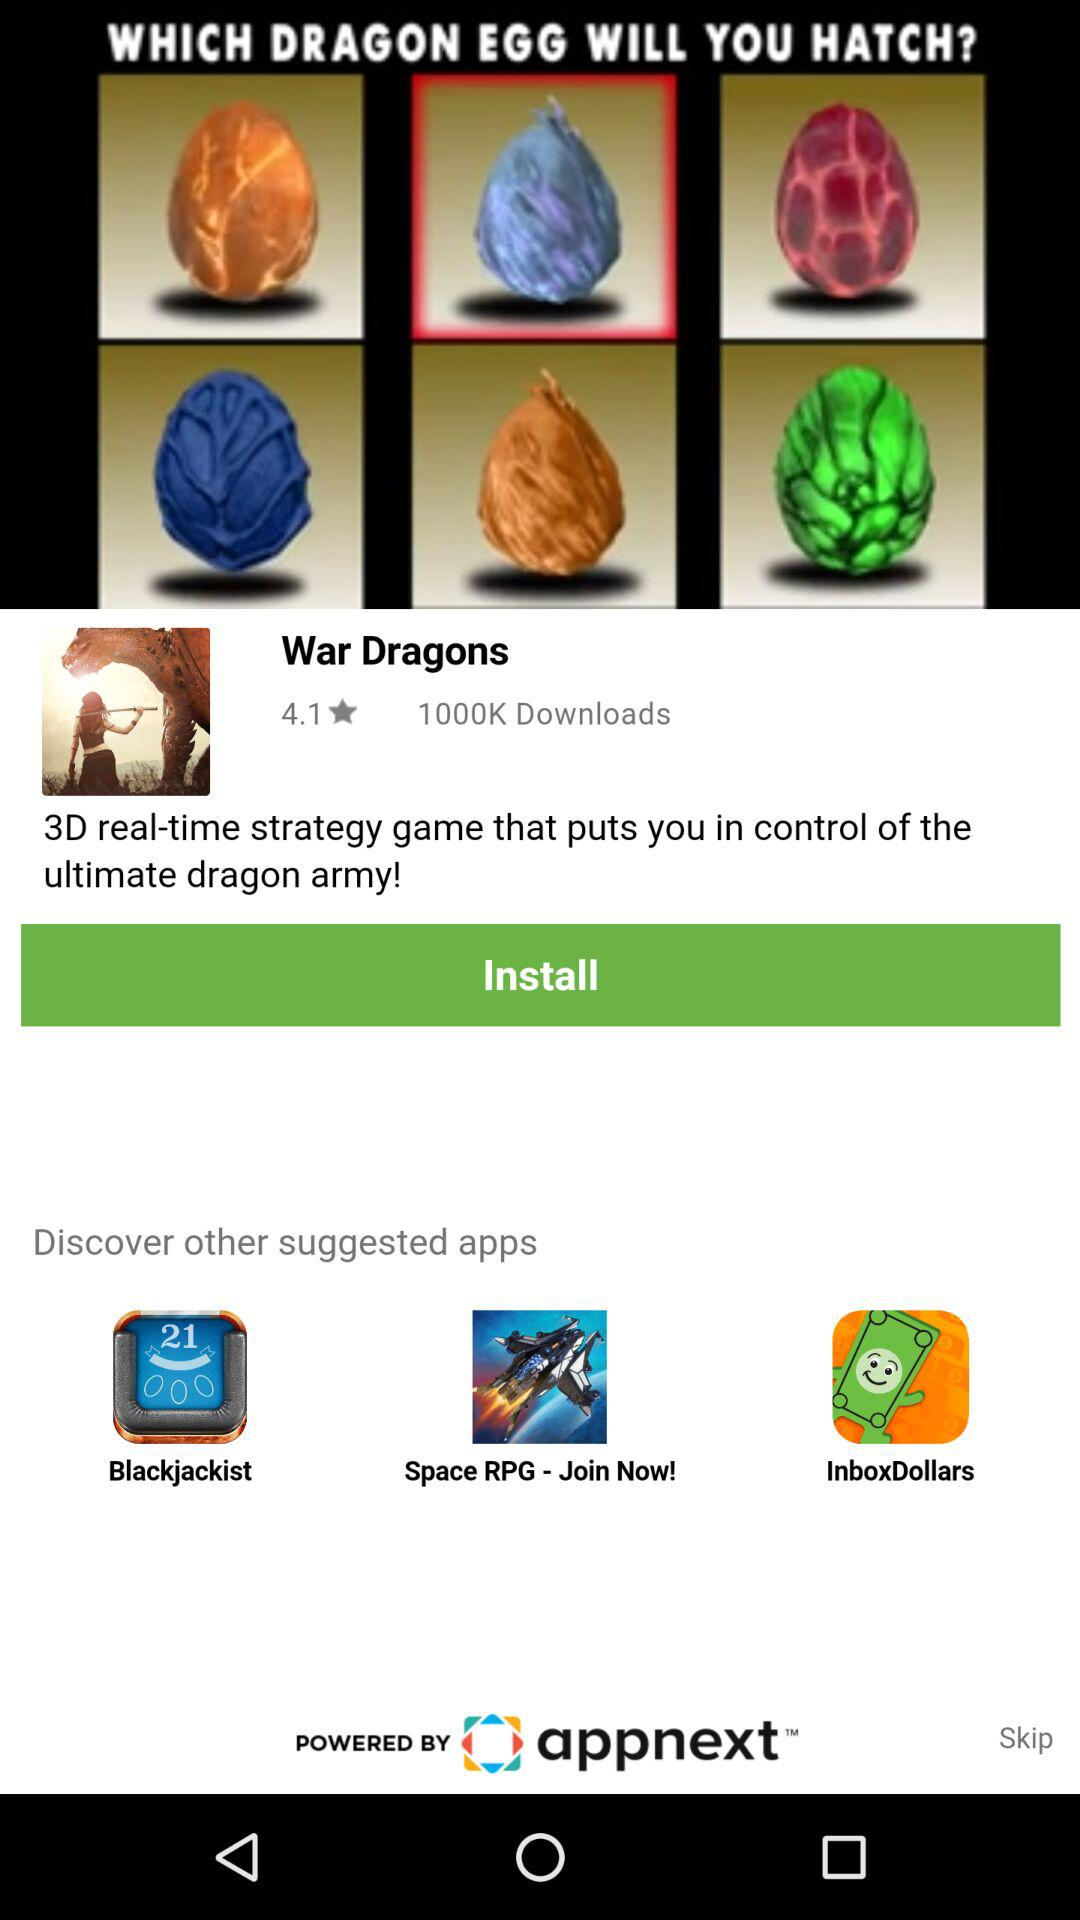How many downloads are there? There are 1000K downloads. 